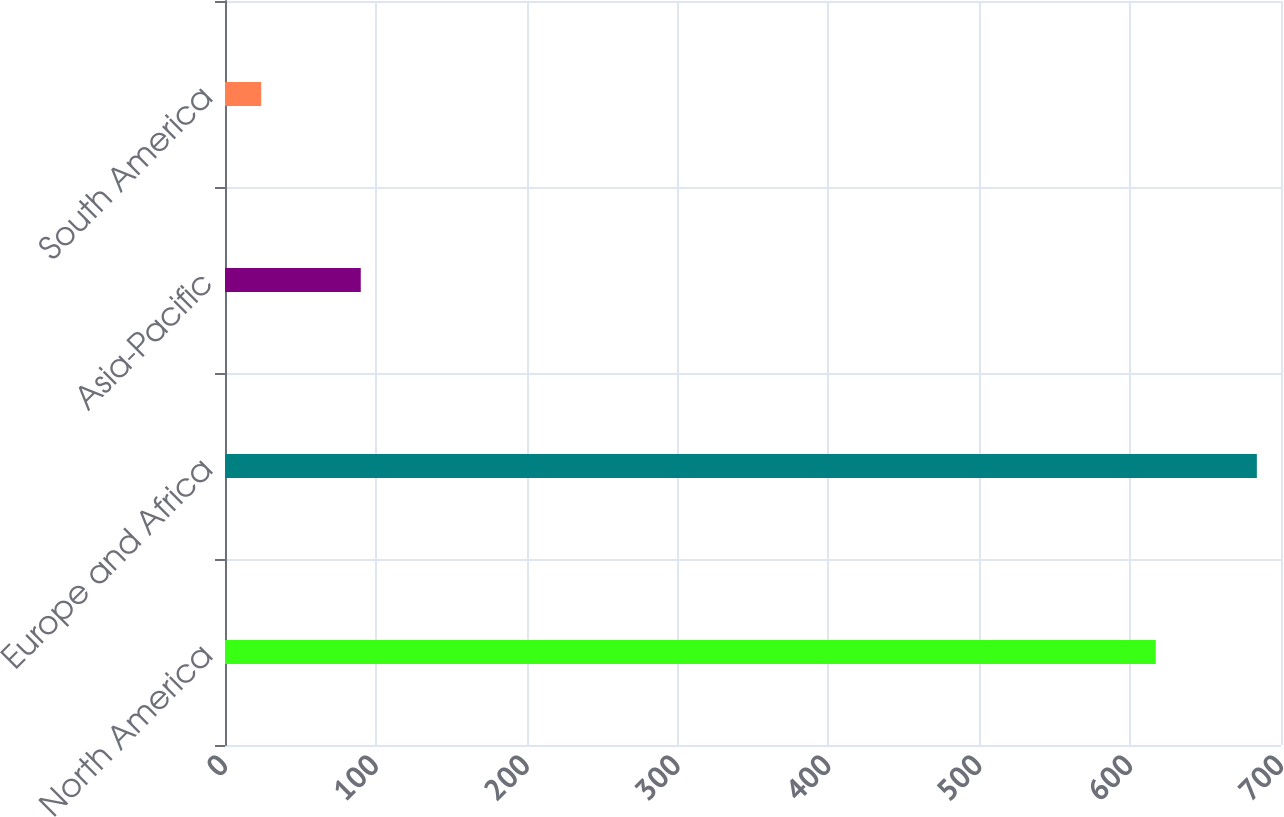Convert chart. <chart><loc_0><loc_0><loc_500><loc_500><bar_chart><fcel>North America<fcel>Europe and Africa<fcel>Asia-Pacific<fcel>South America<nl><fcel>617<fcel>684<fcel>90<fcel>24<nl></chart> 